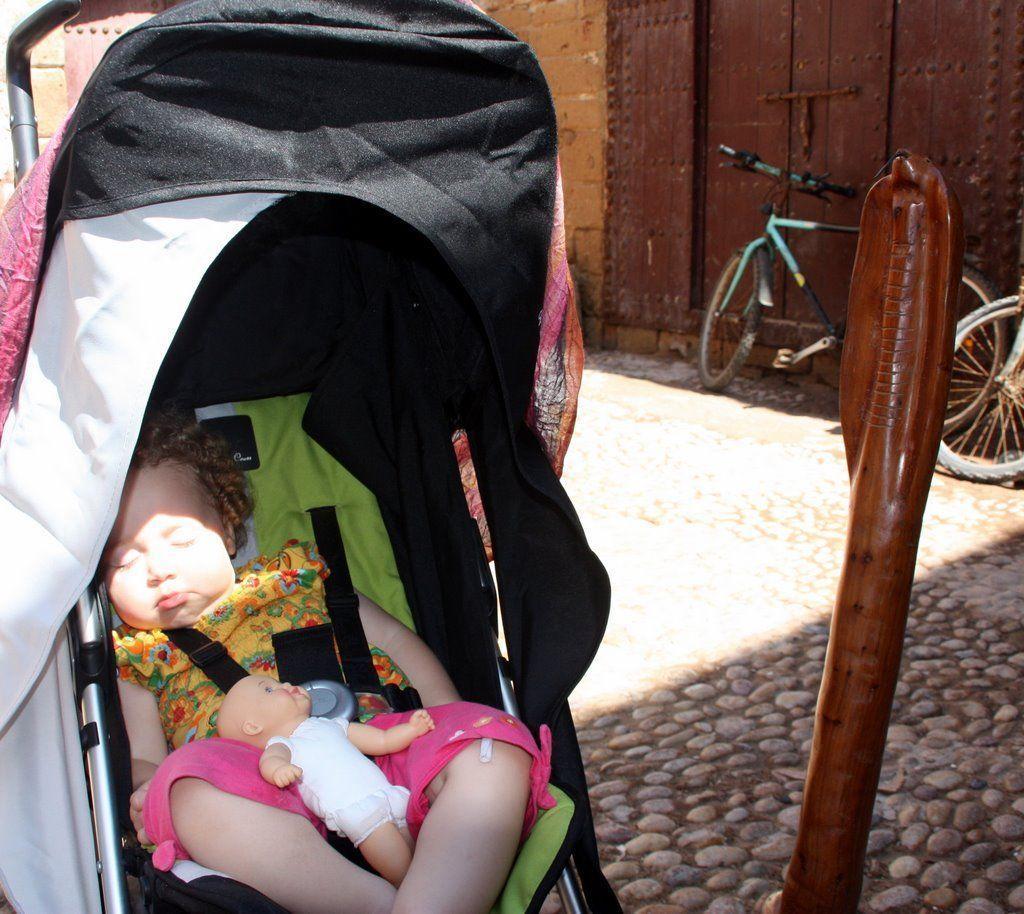In one or two sentences, can you explain what this image depicts? In this image there is a baby sitting in the baby trolley. There is a doll on the lap of the baby. Right side there is an object on the stone path. Right side there are bicycles kept near the wall having a door. 